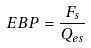<formula> <loc_0><loc_0><loc_500><loc_500>E B P = \frac { F _ { s } } { Q _ { e s } }</formula> 